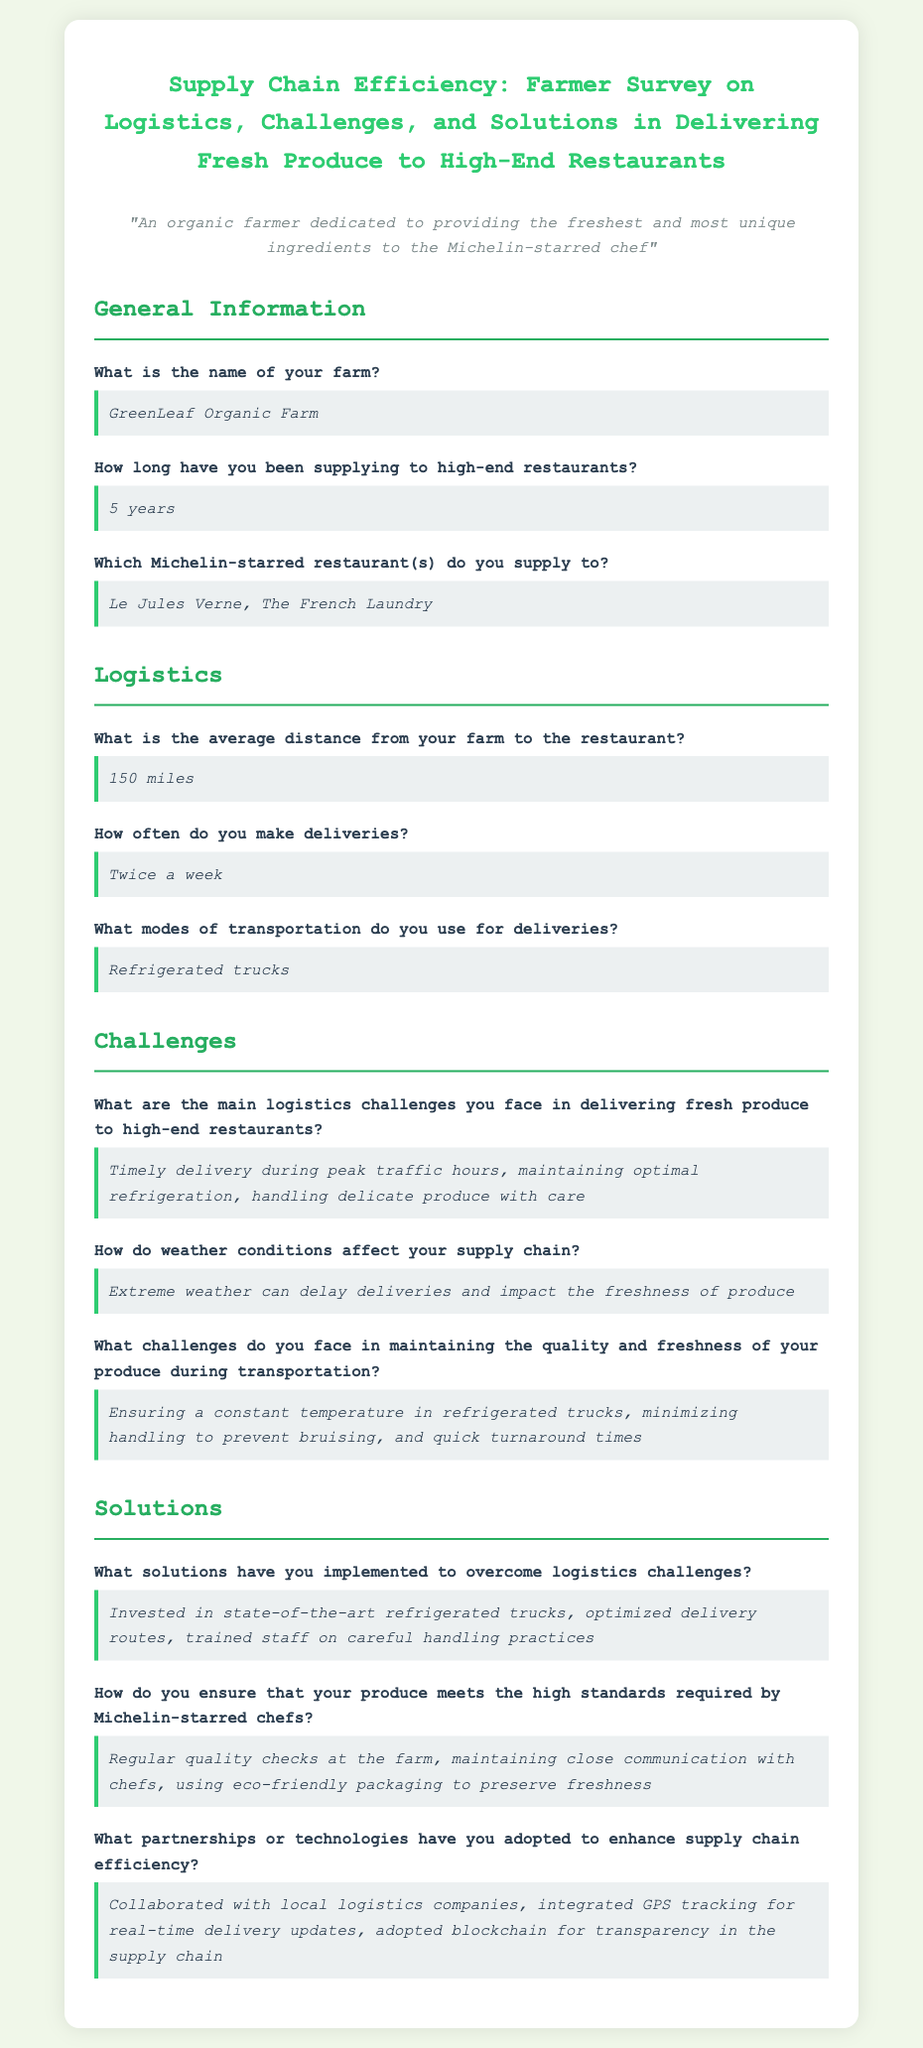What is the name of the farm? The name of the farm is stated in the General Information section of the document.
Answer: GreenLeaf Organic Farm How long has the farm been supplying to high-end restaurants? The duration is mentioned directly in the General Information segment.
Answer: 5 years Which Michelin-starred restaurant does the farm supply to? The specific restaurants supplied by the farm are included in the General Information section.
Answer: Le Jules Verne, The French Laundry What is the average distance from the farm to the restaurant? This information is provided in the Logistics section of the document.
Answer: 150 miles What are the main logistics challenges faced in delivering fresh produce? The challenges are listed in the Challenges section of the document.
Answer: Timely delivery during peak traffic hours, maintaining optimal refrigeration, handling delicate produce with care What solutions has the farm implemented to overcome logistics challenges? The solutions are outlined in the Solutions section of the survey.
Answer: Invested in state-of-the-art refrigerated trucks, optimized delivery routes, trained staff on careful handling practices How often does the farm make deliveries? The frequency of deliveries is mentioned in the Logistics section.
Answer: Twice a week What mode of transportation does the farm use for deliveries? The type of transportation used is specified in the Logistics part of the document.
Answer: Refrigerated trucks What technologies have been adopted to enhance supply chain efficiency? This information is described in the Solutions section of the survey.
Answer: Collaborated with local logistics companies, integrated GPS tracking for real-time delivery updates, adopted blockchain for transparency in the supply chain 